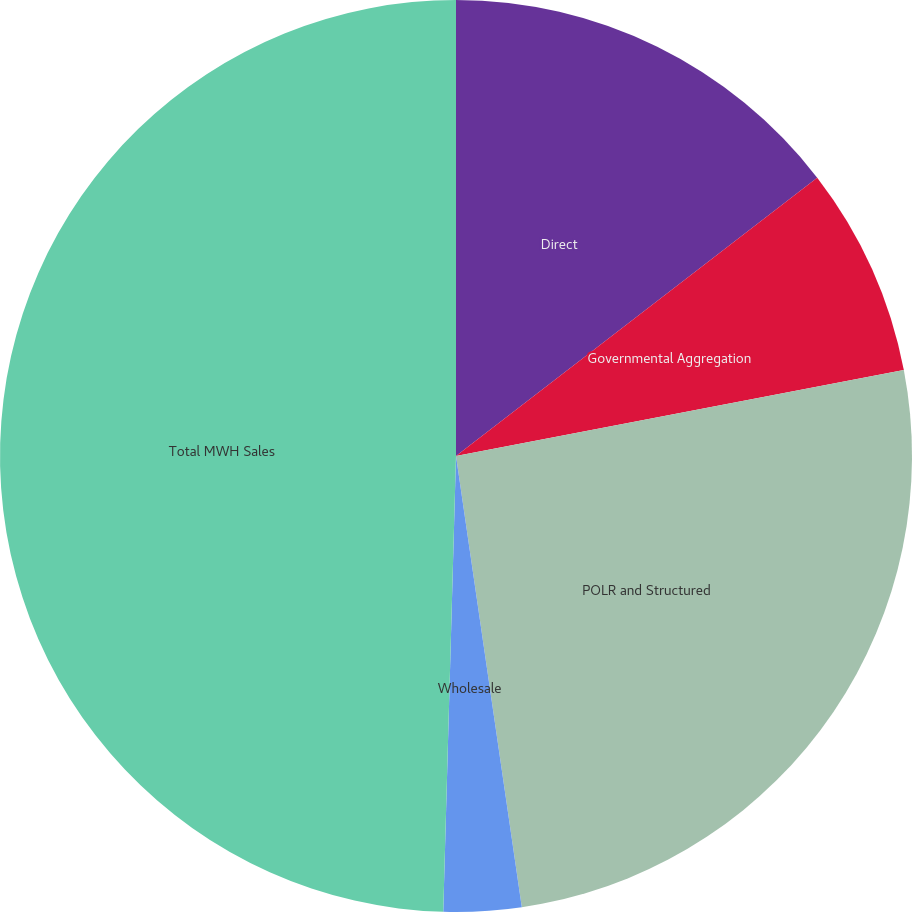Convert chart. <chart><loc_0><loc_0><loc_500><loc_500><pie_chart><fcel>Direct<fcel>Governmental Aggregation<fcel>POLR and Structured<fcel>Wholesale<fcel>Total MWH Sales<nl><fcel>14.55%<fcel>7.43%<fcel>25.71%<fcel>2.75%<fcel>49.55%<nl></chart> 